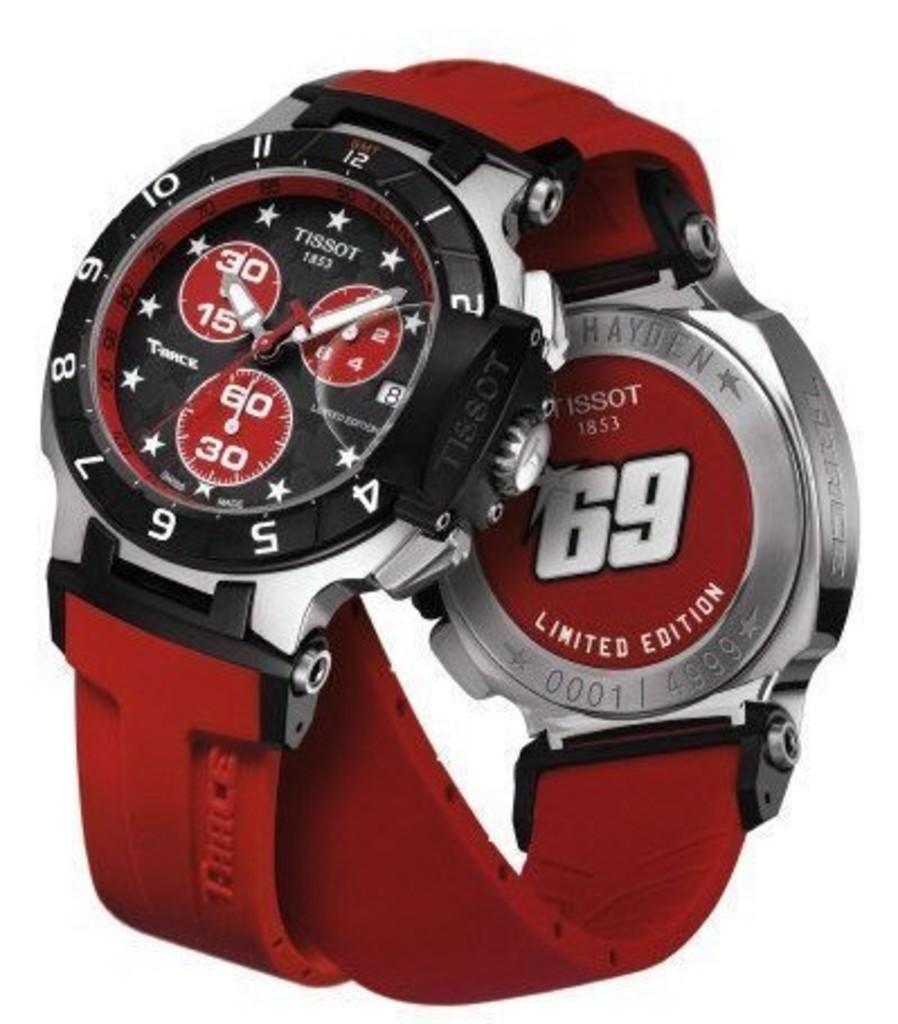What edition is this watch?
Your response must be concise. Limited. How many of watches were available in this limited release?
Offer a very short reply. 4999. 